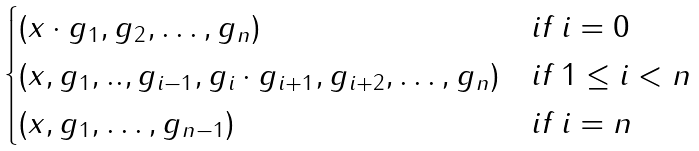Convert formula to latex. <formula><loc_0><loc_0><loc_500><loc_500>\begin{cases} ( x \cdot g _ { 1 } , g _ { 2 } , \dots , g _ { n } ) & i f \, i = 0 \\ ( x , g _ { 1 } , . . , g _ { i - 1 } , g _ { i } \cdot g _ { i + 1 } , g _ { i + 2 } , \dots , g _ { n } ) & i f \, 1 \leq i < n \\ ( x , g _ { 1 } , \dots , g _ { n - 1 } ) & i f \, i = n \end{cases}</formula> 